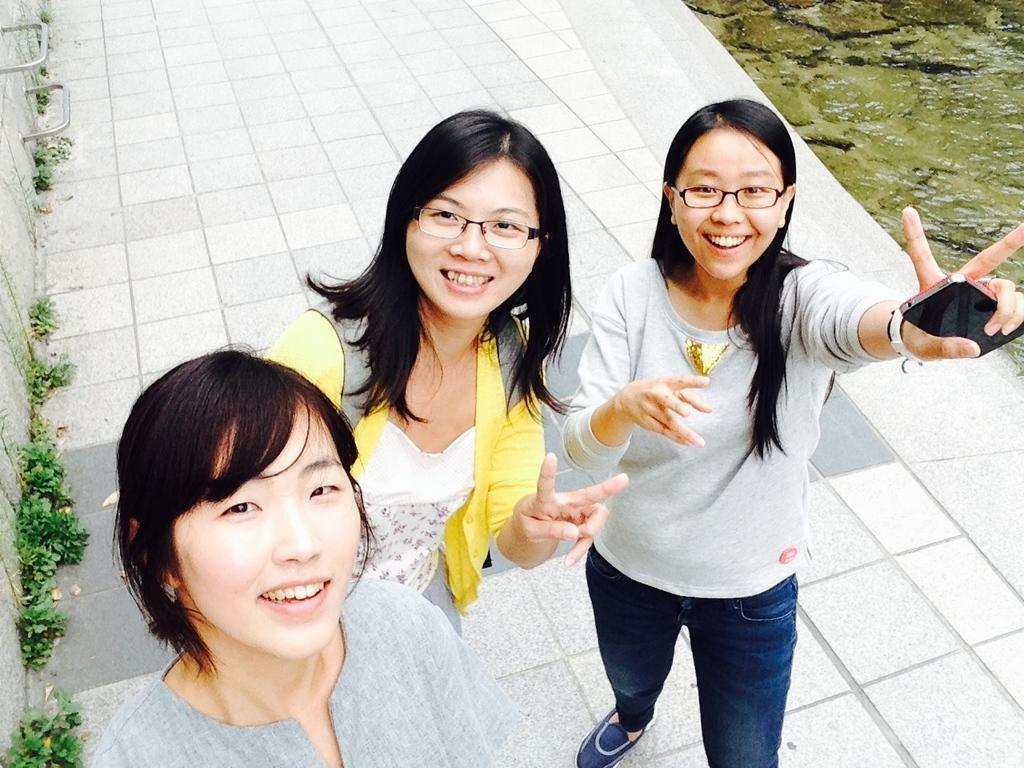How many people are in the image? There are three persons in the image. What are the persons doing in the image? The persons are posing for a camera. What expressions do the persons have in the image? The persons are smiling in the image. What are the persons wearing in the image? The persons are wearing spectacles in the image. What else can be seen in the image besides the persons? There are plants in the image. What type of scissors can be seen in the image? There are no scissors present in the image. Can you describe the locket worn by one of the persons in the image? There is no locket mentioned or visible in the image. 